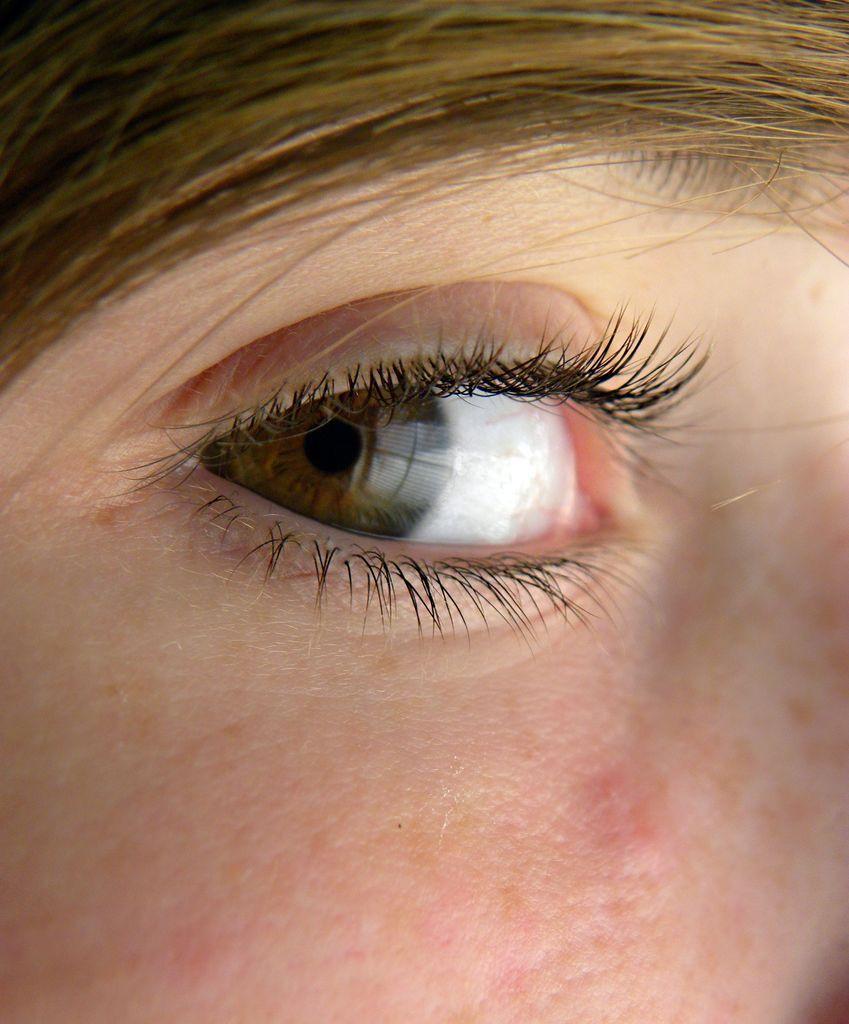Describe this image in one or two sentences. This image contains a human face having an eye and eyebrow which is covered with hair. 